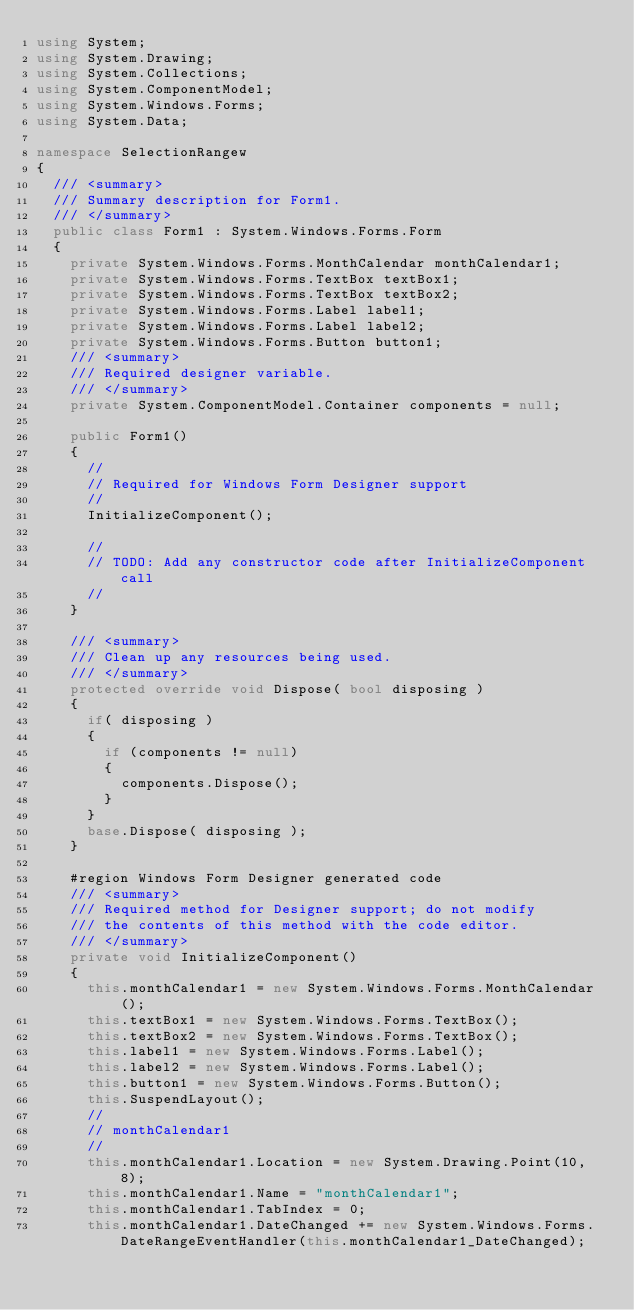<code> <loc_0><loc_0><loc_500><loc_500><_C#_>using System;
using System.Drawing;
using System.Collections;
using System.ComponentModel;
using System.Windows.Forms;
using System.Data;

namespace SelectionRangew
{
	/// <summary>
	/// Summary description for Form1.
	/// </summary>
	public class Form1 : System.Windows.Forms.Form
	{
		private System.Windows.Forms.MonthCalendar monthCalendar1;
		private System.Windows.Forms.TextBox textBox1;
		private System.Windows.Forms.TextBox textBox2;
		private System.Windows.Forms.Label label1;
		private System.Windows.Forms.Label label2;
		private System.Windows.Forms.Button button1;
		/// <summary>
		/// Required designer variable.
		/// </summary>
		private System.ComponentModel.Container components = null;

		public Form1()
		{
			//
			// Required for Windows Form Designer support
			//
			InitializeComponent();

			//
			// TODO: Add any constructor code after InitializeComponent call
			//
		}

		/// <summary>
		/// Clean up any resources being used.
		/// </summary>
		protected override void Dispose( bool disposing )
		{
			if( disposing )
			{
				if (components != null) 
				{
					components.Dispose();
				}
			}
			base.Dispose( disposing );
		}

		#region Windows Form Designer generated code
		/// <summary>
		/// Required method for Designer support; do not modify
		/// the contents of this method with the code editor.
		/// </summary>
		private void InitializeComponent()
		{
			this.monthCalendar1 = new System.Windows.Forms.MonthCalendar();
			this.textBox1 = new System.Windows.Forms.TextBox();
			this.textBox2 = new System.Windows.Forms.TextBox();
			this.label1 = new System.Windows.Forms.Label();
			this.label2 = new System.Windows.Forms.Label();
			this.button1 = new System.Windows.Forms.Button();
			this.SuspendLayout();
			// 
			// monthCalendar1
			// 
			this.monthCalendar1.Location = new System.Drawing.Point(10, 8);
			this.monthCalendar1.Name = "monthCalendar1";
			this.monthCalendar1.TabIndex = 0;
			this.monthCalendar1.DateChanged += new System.Windows.Forms.DateRangeEventHandler(this.monthCalendar1_DateChanged);</code> 